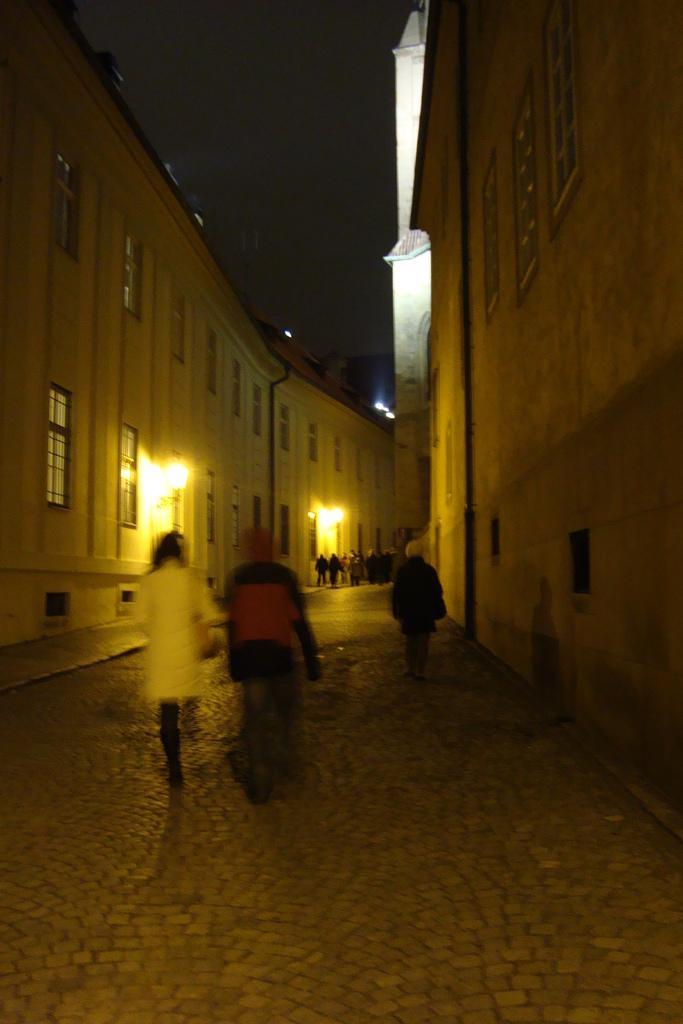How would you summarize this image in a sentence or two? In the center of the image there are people walking on the road. To both sides of the image there are buildings. At the top of the image there is sky. There are windows. 